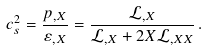Convert formula to latex. <formula><loc_0><loc_0><loc_500><loc_500>c _ { s } ^ { 2 } = \frac { p _ { , X } } { \varepsilon _ { , X } } = \frac { { \mathcal { L } } _ { , X } } { { \mathcal { L } } _ { , X } + 2 X { \mathcal { L } } _ { , X X } } \, .</formula> 